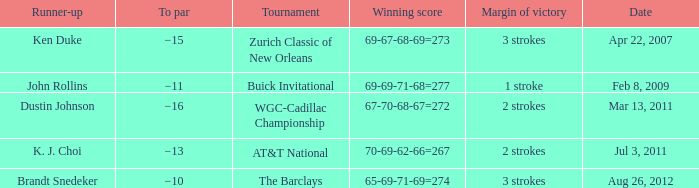A tournament on which date has a margin of victory of 2 strokes and a par of −16? Mar 13, 2011. 